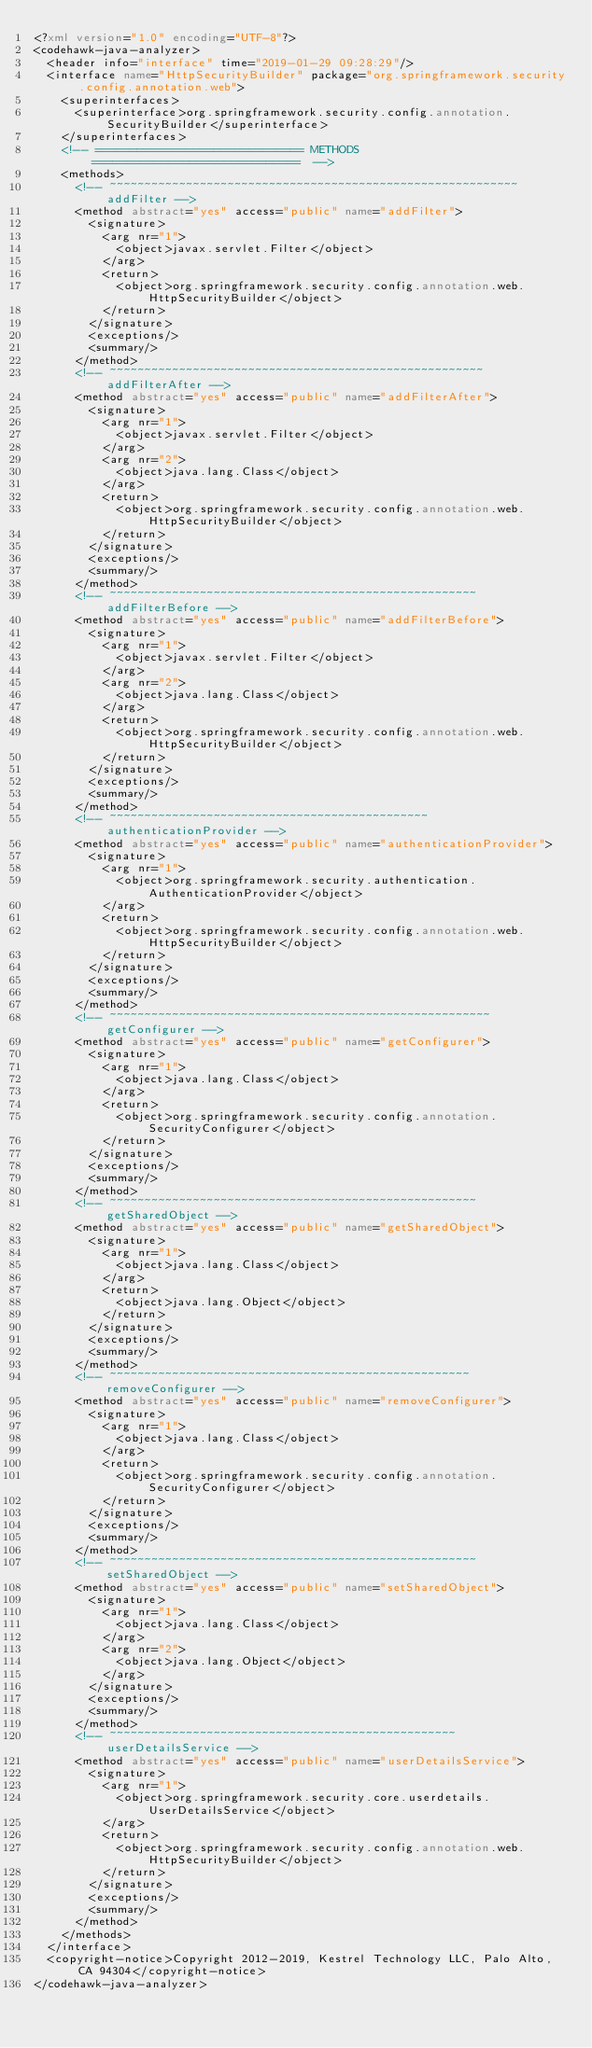<code> <loc_0><loc_0><loc_500><loc_500><_XML_><?xml version="1.0" encoding="UTF-8"?>
<codehawk-java-analyzer>
  <header info="interface" time="2019-01-29 09:28:29"/>
  <interface name="HttpSecurityBuilder" package="org.springframework.security.config.annotation.web">
    <superinterfaces>
      <superinterface>org.springframework.security.config.annotation.SecurityBuilder</superinterface>
    </superinterfaces>
    <!-- ============================== METHODS ==============================  -->
    <methods>
      <!-- ~~~~~~~~~~~~~~~~~~~~~~~~~~~~~~~~~~~~~~~~~~~~~~~~~~~~~~~~~~~ addFilter -->
      <method abstract="yes" access="public" name="addFilter">
        <signature>
          <arg nr="1">
            <object>javax.servlet.Filter</object>
          </arg>
          <return>
            <object>org.springframework.security.config.annotation.web.HttpSecurityBuilder</object>
          </return>
        </signature>
        <exceptions/>
        <summary/>
      </method>
      <!-- ~~~~~~~~~~~~~~~~~~~~~~~~~~~~~~~~~~~~~~~~~~~~~~~~~~~~~~ addFilterAfter -->
      <method abstract="yes" access="public" name="addFilterAfter">
        <signature>
          <arg nr="1">
            <object>javax.servlet.Filter</object>
          </arg>
          <arg nr="2">
            <object>java.lang.Class</object>
          </arg>
          <return>
            <object>org.springframework.security.config.annotation.web.HttpSecurityBuilder</object>
          </return>
        </signature>
        <exceptions/>
        <summary/>
      </method>
      <!-- ~~~~~~~~~~~~~~~~~~~~~~~~~~~~~~~~~~~~~~~~~~~~~~~~~~~~~ addFilterBefore -->
      <method abstract="yes" access="public" name="addFilterBefore">
        <signature>
          <arg nr="1">
            <object>javax.servlet.Filter</object>
          </arg>
          <arg nr="2">
            <object>java.lang.Class</object>
          </arg>
          <return>
            <object>org.springframework.security.config.annotation.web.HttpSecurityBuilder</object>
          </return>
        </signature>
        <exceptions/>
        <summary/>
      </method>
      <!-- ~~~~~~~~~~~~~~~~~~~~~~~~~~~~~~~~~~~~~~~~~~~~~~ authenticationProvider -->
      <method abstract="yes" access="public" name="authenticationProvider">
        <signature>
          <arg nr="1">
            <object>org.springframework.security.authentication.AuthenticationProvider</object>
          </arg>
          <return>
            <object>org.springframework.security.config.annotation.web.HttpSecurityBuilder</object>
          </return>
        </signature>
        <exceptions/>
        <summary/>
      </method>
      <!-- ~~~~~~~~~~~~~~~~~~~~~~~~~~~~~~~~~~~~~~~~~~~~~~~~~~~~~~~ getConfigurer -->
      <method abstract="yes" access="public" name="getConfigurer">
        <signature>
          <arg nr="1">
            <object>java.lang.Class</object>
          </arg>
          <return>
            <object>org.springframework.security.config.annotation.SecurityConfigurer</object>
          </return>
        </signature>
        <exceptions/>
        <summary/>
      </method>
      <!-- ~~~~~~~~~~~~~~~~~~~~~~~~~~~~~~~~~~~~~~~~~~~~~~~~~~~~~ getSharedObject -->
      <method abstract="yes" access="public" name="getSharedObject">
        <signature>
          <arg nr="1">
            <object>java.lang.Class</object>
          </arg>
          <return>
            <object>java.lang.Object</object>
          </return>
        </signature>
        <exceptions/>
        <summary/>
      </method>
      <!-- ~~~~~~~~~~~~~~~~~~~~~~~~~~~~~~~~~~~~~~~~~~~~~~~~~~~~ removeConfigurer -->
      <method abstract="yes" access="public" name="removeConfigurer">
        <signature>
          <arg nr="1">
            <object>java.lang.Class</object>
          </arg>
          <return>
            <object>org.springframework.security.config.annotation.SecurityConfigurer</object>
          </return>
        </signature>
        <exceptions/>
        <summary/>
      </method>
      <!-- ~~~~~~~~~~~~~~~~~~~~~~~~~~~~~~~~~~~~~~~~~~~~~~~~~~~~~ setSharedObject -->
      <method abstract="yes" access="public" name="setSharedObject">
        <signature>
          <arg nr="1">
            <object>java.lang.Class</object>
          </arg>
          <arg nr="2">
            <object>java.lang.Object</object>
          </arg>
        </signature>
        <exceptions/>
        <summary/>
      </method>
      <!-- ~~~~~~~~~~~~~~~~~~~~~~~~~~~~~~~~~~~~~~~~~~~~~~~~~~ userDetailsService -->
      <method abstract="yes" access="public" name="userDetailsService">
        <signature>
          <arg nr="1">
            <object>org.springframework.security.core.userdetails.UserDetailsService</object>
          </arg>
          <return>
            <object>org.springframework.security.config.annotation.web.HttpSecurityBuilder</object>
          </return>
        </signature>
        <exceptions/>
        <summary/>
      </method>
    </methods>
  </interface>
  <copyright-notice>Copyright 2012-2019, Kestrel Technology LLC, Palo Alto, CA 94304</copyright-notice>
</codehawk-java-analyzer>
</code> 